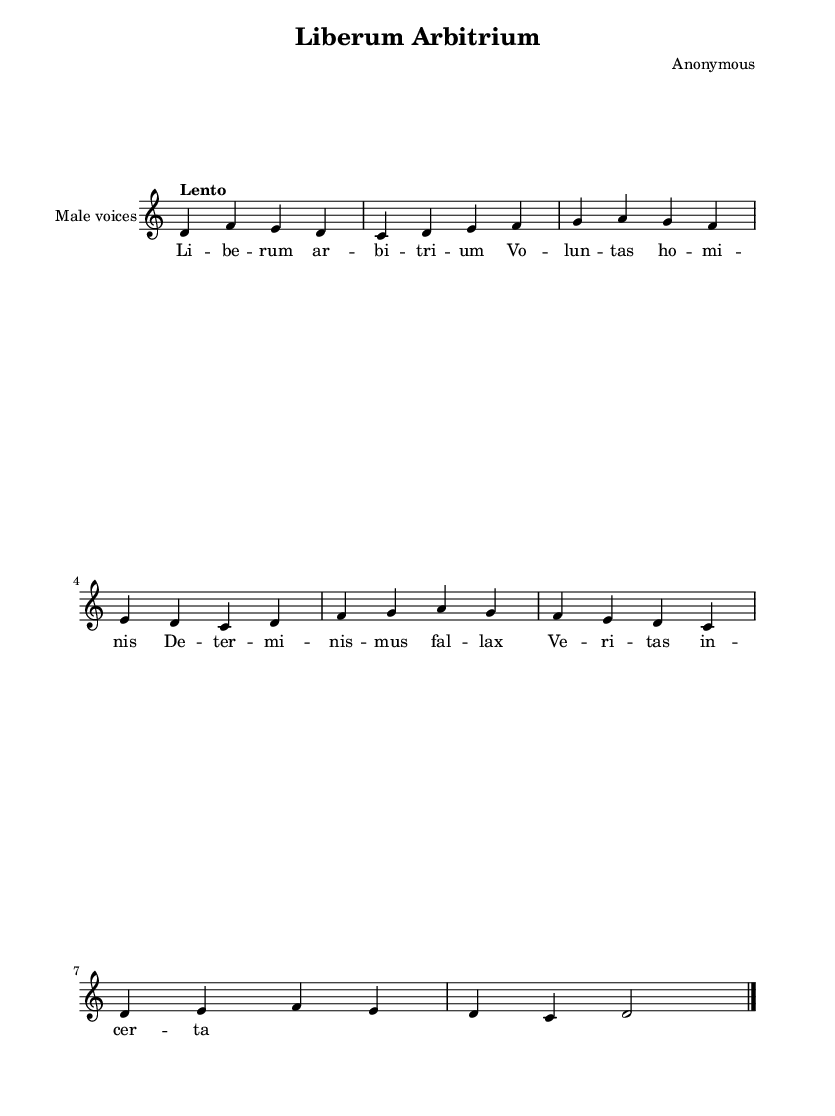What is the key signature of this music? The key signature is indicated by the absence of sharps or flats in the staff at the beginning of the piece. Dorian mode commonly uses a key signature of one sharp, but with the given information, it corresponds to D Dorian with no additional accidentals.
Answer: D Dorian What is the time signature of this music? The time signature is shown at the beginning of the score, represented as a fraction. In this case, it is 4 over 4, indicating four beats in each measure and the quarter note gets one beat.
Answer: 4/4 What is the tempo marking in this sheet music? The tempo marking is located at the beginning of the score and indicates the speed at which the music should be played. Here, it states "Lento," meaning slow.
Answer: Lento How many measures are in the melody? By counting the distinct groups of notes separated by vertical lines (bars) in the melody part, we see there are a total of eight measures present.
Answer: 8 Which voice type is indicated for this piece? The voice type is specified in the score section under the staff where the instrument name is placed. This identifies the intended vocal group for this piece as "Male voices."
Answer: Male voices What is the central theme expressed in the lyrics? The lyrics discuss concepts related to free will and truth, implying a philosophical discourse on human agency and belief, as denoted in the text "Liberum Arbitrium."
Answer: Free will Explain the significance of the term "Liberum Arbitrium" in relation to free will. The term "Liberum Arbitrium," or "Free Will," encapsulates the fundamental philosophical debate around human autonomy and moral choice. In the context of Gregorian chants, it reflects the interplay between divine providence and human agency, urging a reflection on the individual's role in moral decisions.
Answer: Significance of free will 